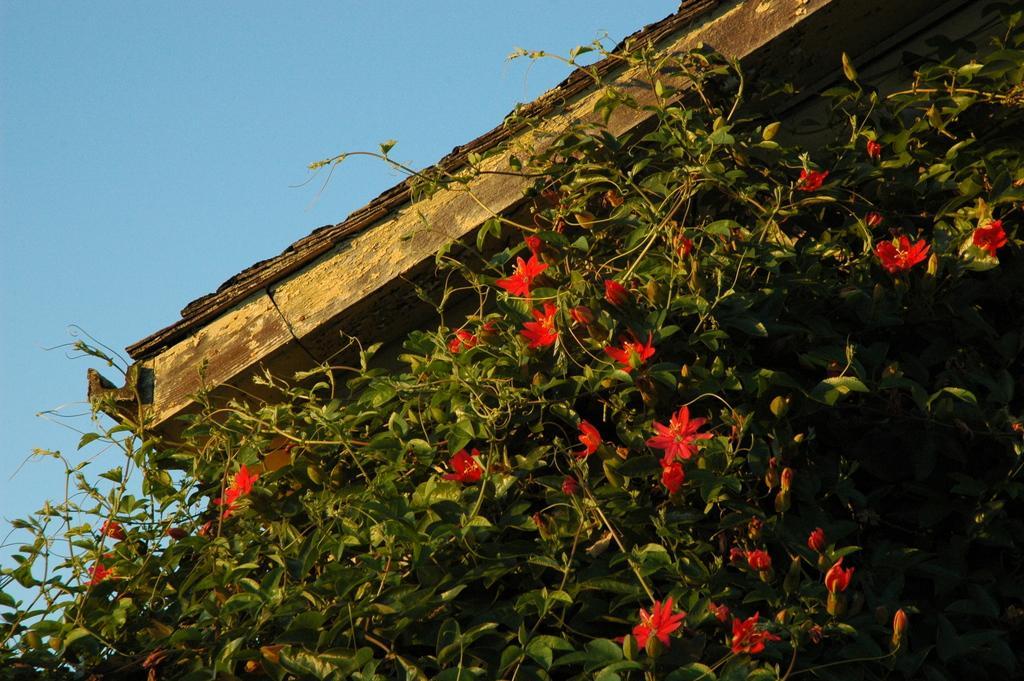In one or two sentences, can you explain what this image depicts? In this picture we can see some leaves and flowers in the front, there is the sky at the top of the picture. 